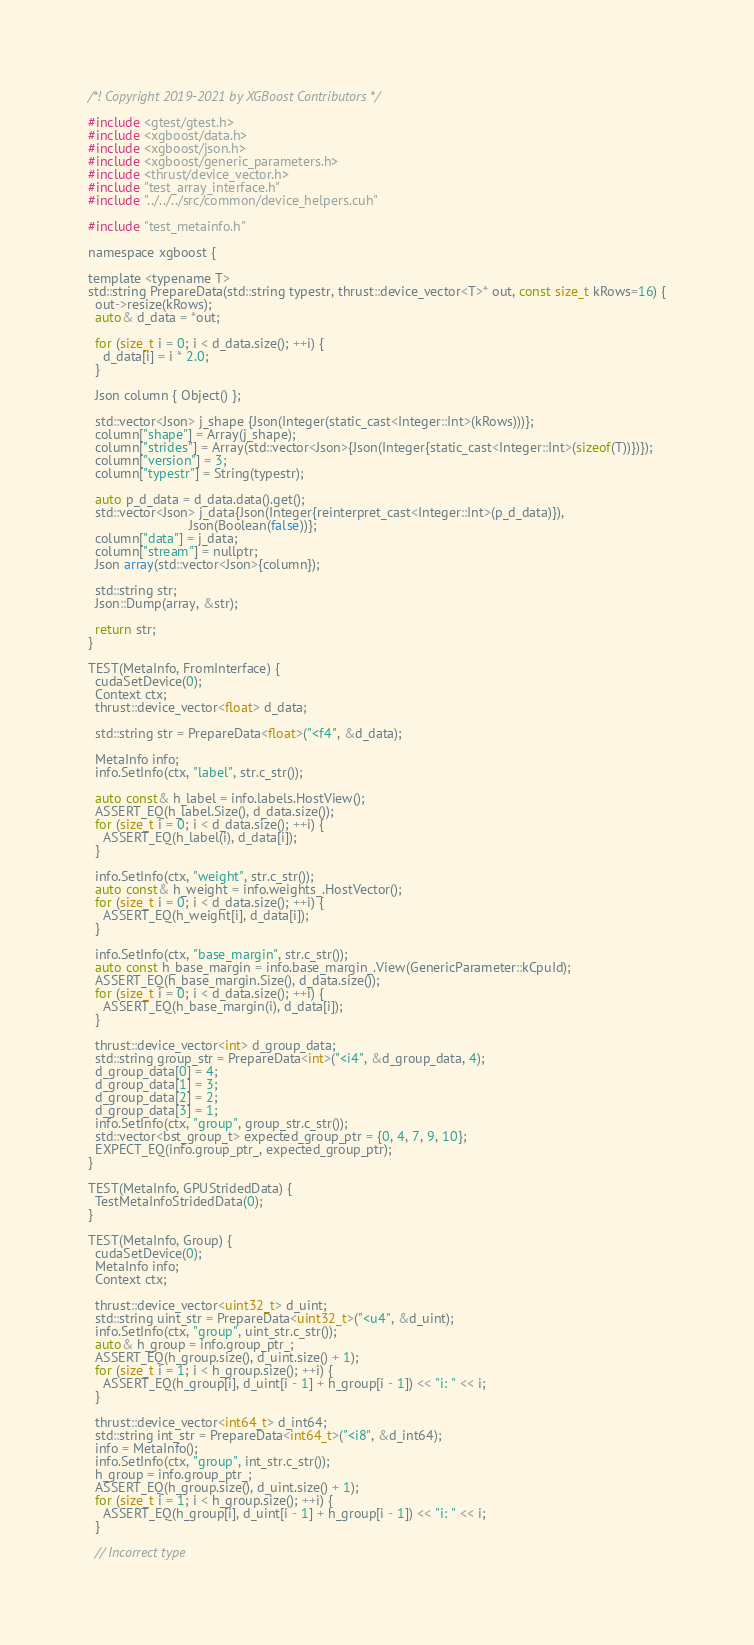<code> <loc_0><loc_0><loc_500><loc_500><_Cuda_>/*! Copyright 2019-2021 by XGBoost Contributors */

#include <gtest/gtest.h>
#include <xgboost/data.h>
#include <xgboost/json.h>
#include <xgboost/generic_parameters.h>
#include <thrust/device_vector.h>
#include "test_array_interface.h"
#include "../../../src/common/device_helpers.cuh"

#include "test_metainfo.h"

namespace xgboost {

template <typename T>
std::string PrepareData(std::string typestr, thrust::device_vector<T>* out, const size_t kRows=16) {
  out->resize(kRows);
  auto& d_data = *out;

  for (size_t i = 0; i < d_data.size(); ++i) {
    d_data[i] = i * 2.0;
  }

  Json column { Object() };

  std::vector<Json> j_shape {Json(Integer(static_cast<Integer::Int>(kRows)))};
  column["shape"] = Array(j_shape);
  column["strides"] = Array(std::vector<Json>{Json(Integer{static_cast<Integer::Int>(sizeof(T))})});
  column["version"] = 3;
  column["typestr"] = String(typestr);

  auto p_d_data = d_data.data().get();
  std::vector<Json> j_data{Json(Integer{reinterpret_cast<Integer::Int>(p_d_data)}),
                           Json(Boolean(false))};
  column["data"] = j_data;
  column["stream"] = nullptr;
  Json array(std::vector<Json>{column});

  std::string str;
  Json::Dump(array, &str);

  return str;
}

TEST(MetaInfo, FromInterface) {
  cudaSetDevice(0);
  Context ctx;
  thrust::device_vector<float> d_data;

  std::string str = PrepareData<float>("<f4", &d_data);

  MetaInfo info;
  info.SetInfo(ctx, "label", str.c_str());

  auto const& h_label = info.labels.HostView();
  ASSERT_EQ(h_label.Size(), d_data.size());
  for (size_t i = 0; i < d_data.size(); ++i) {
    ASSERT_EQ(h_label(i), d_data[i]);
  }

  info.SetInfo(ctx, "weight", str.c_str());
  auto const& h_weight = info.weights_.HostVector();
  for (size_t i = 0; i < d_data.size(); ++i) {
    ASSERT_EQ(h_weight[i], d_data[i]);
  }

  info.SetInfo(ctx, "base_margin", str.c_str());
  auto const h_base_margin = info.base_margin_.View(GenericParameter::kCpuId);
  ASSERT_EQ(h_base_margin.Size(), d_data.size());
  for (size_t i = 0; i < d_data.size(); ++i) {
    ASSERT_EQ(h_base_margin(i), d_data[i]);
  }

  thrust::device_vector<int> d_group_data;
  std::string group_str = PrepareData<int>("<i4", &d_group_data, 4);
  d_group_data[0] = 4;
  d_group_data[1] = 3;
  d_group_data[2] = 2;
  d_group_data[3] = 1;
  info.SetInfo(ctx, "group", group_str.c_str());
  std::vector<bst_group_t> expected_group_ptr = {0, 4, 7, 9, 10};
  EXPECT_EQ(info.group_ptr_, expected_group_ptr);
}

TEST(MetaInfo, GPUStridedData) {
  TestMetaInfoStridedData(0);
}

TEST(MetaInfo, Group) {
  cudaSetDevice(0);
  MetaInfo info;
  Context ctx;

  thrust::device_vector<uint32_t> d_uint;
  std::string uint_str = PrepareData<uint32_t>("<u4", &d_uint);
  info.SetInfo(ctx, "group", uint_str.c_str());
  auto& h_group = info.group_ptr_;
  ASSERT_EQ(h_group.size(), d_uint.size() + 1);
  for (size_t i = 1; i < h_group.size(); ++i) {
    ASSERT_EQ(h_group[i], d_uint[i - 1] + h_group[i - 1]) << "i: " << i;
  }

  thrust::device_vector<int64_t> d_int64;
  std::string int_str = PrepareData<int64_t>("<i8", &d_int64);
  info = MetaInfo();
  info.SetInfo(ctx, "group", int_str.c_str());
  h_group = info.group_ptr_;
  ASSERT_EQ(h_group.size(), d_uint.size() + 1);
  for (size_t i = 1; i < h_group.size(); ++i) {
    ASSERT_EQ(h_group[i], d_uint[i - 1] + h_group[i - 1]) << "i: " << i;
  }

  // Incorrect type</code> 